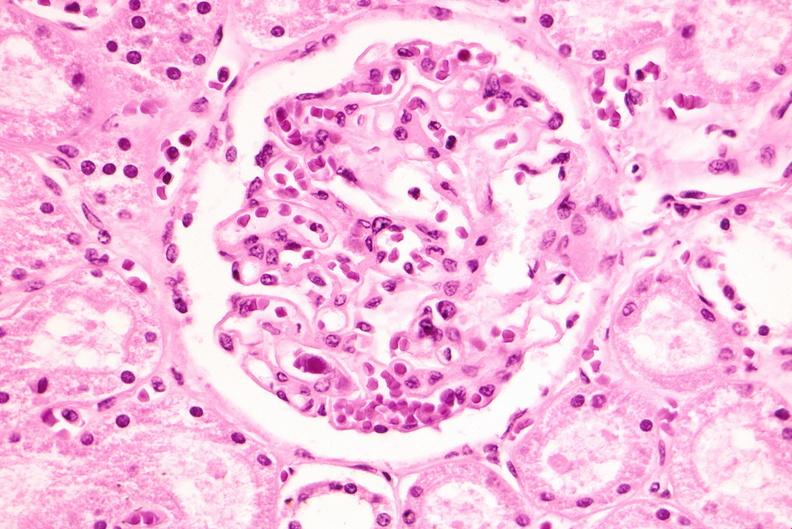what does this image show?
Answer the question using a single word or phrase. Kidney 